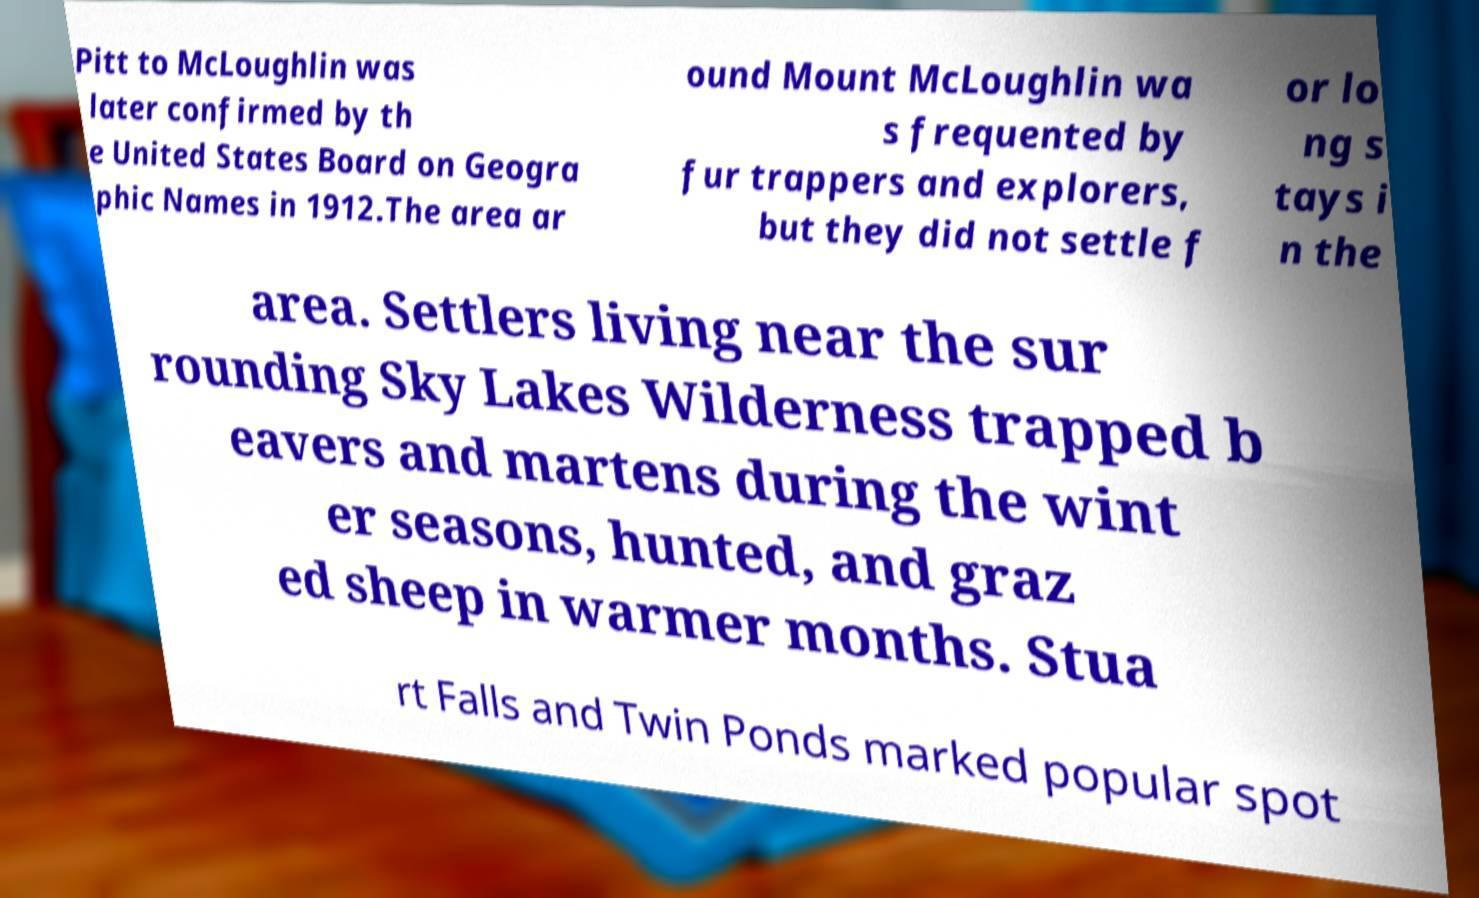I need the written content from this picture converted into text. Can you do that? Pitt to McLoughlin was later confirmed by th e United States Board on Geogra phic Names in 1912.The area ar ound Mount McLoughlin wa s frequented by fur trappers and explorers, but they did not settle f or lo ng s tays i n the area. Settlers living near the sur rounding Sky Lakes Wilderness trapped b eavers and martens during the wint er seasons, hunted, and graz ed sheep in warmer months. Stua rt Falls and Twin Ponds marked popular spot 